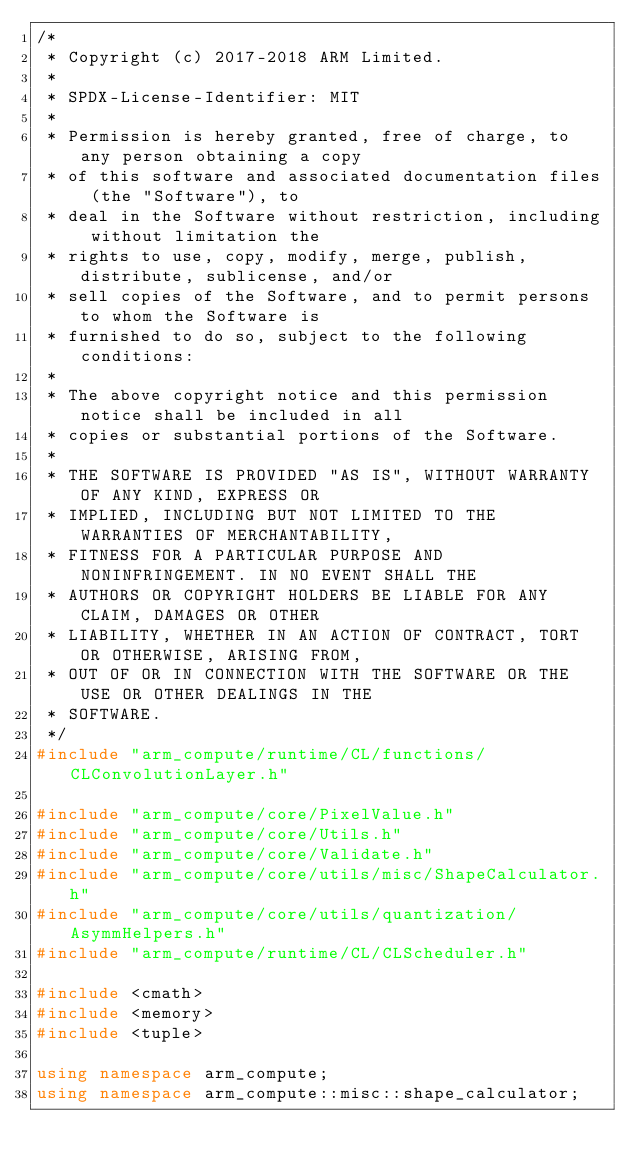<code> <loc_0><loc_0><loc_500><loc_500><_C++_>/*
 * Copyright (c) 2017-2018 ARM Limited.
 *
 * SPDX-License-Identifier: MIT
 *
 * Permission is hereby granted, free of charge, to any person obtaining a copy
 * of this software and associated documentation files (the "Software"), to
 * deal in the Software without restriction, including without limitation the
 * rights to use, copy, modify, merge, publish, distribute, sublicense, and/or
 * sell copies of the Software, and to permit persons to whom the Software is
 * furnished to do so, subject to the following conditions:
 *
 * The above copyright notice and this permission notice shall be included in all
 * copies or substantial portions of the Software.
 *
 * THE SOFTWARE IS PROVIDED "AS IS", WITHOUT WARRANTY OF ANY KIND, EXPRESS OR
 * IMPLIED, INCLUDING BUT NOT LIMITED TO THE WARRANTIES OF MERCHANTABILITY,
 * FITNESS FOR A PARTICULAR PURPOSE AND NONINFRINGEMENT. IN NO EVENT SHALL THE
 * AUTHORS OR COPYRIGHT HOLDERS BE LIABLE FOR ANY CLAIM, DAMAGES OR OTHER
 * LIABILITY, WHETHER IN AN ACTION OF CONTRACT, TORT OR OTHERWISE, ARISING FROM,
 * OUT OF OR IN CONNECTION WITH THE SOFTWARE OR THE USE OR OTHER DEALINGS IN THE
 * SOFTWARE.
 */
#include "arm_compute/runtime/CL/functions/CLConvolutionLayer.h"

#include "arm_compute/core/PixelValue.h"
#include "arm_compute/core/Utils.h"
#include "arm_compute/core/Validate.h"
#include "arm_compute/core/utils/misc/ShapeCalculator.h"
#include "arm_compute/core/utils/quantization/AsymmHelpers.h"
#include "arm_compute/runtime/CL/CLScheduler.h"

#include <cmath>
#include <memory>
#include <tuple>

using namespace arm_compute;
using namespace arm_compute::misc::shape_calculator;
</code> 